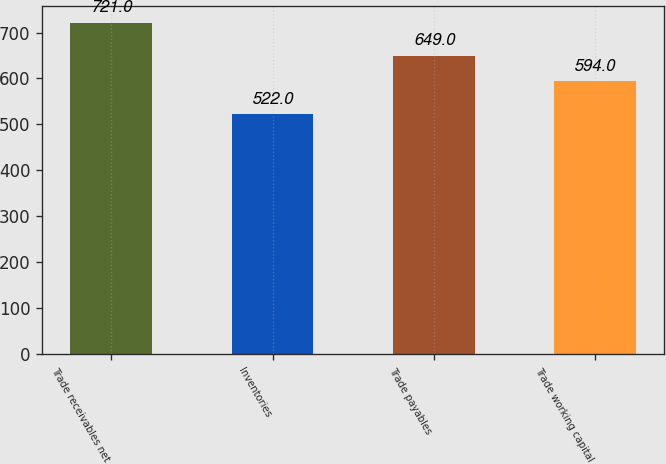<chart> <loc_0><loc_0><loc_500><loc_500><bar_chart><fcel>Trade receivables net<fcel>Inventories<fcel>Trade payables<fcel>Trade working capital<nl><fcel>721<fcel>522<fcel>649<fcel>594<nl></chart> 